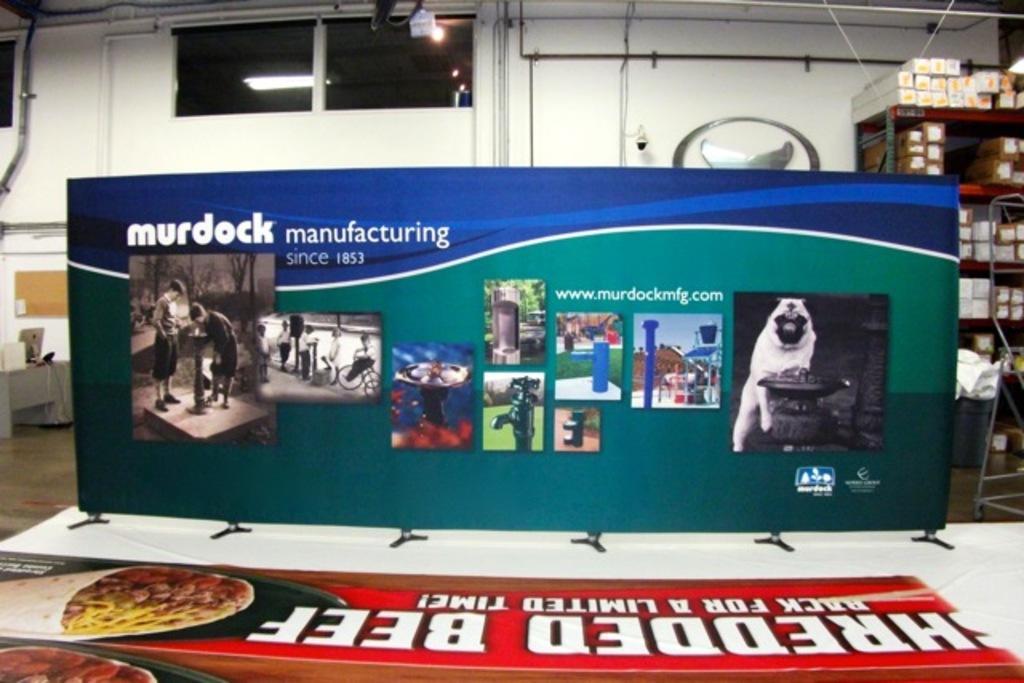Can you describe this image briefly? This picture is taken inside the room. In this image, in the middle, we can see a hoarding, on the hoardings, we can see some pictures and some text written on it. On the right side, we can see a shelf, in the shelf, we can see some boxes. On the left side, we can see a table, on the table, we can see monitor, laptop and some electronic instrument. In the background, we can see a glass window, lights, camera. At the top, we can see some pipes, at the bottom, we can also see a hoarding, on that hoarding, we can see some text and pictures. 